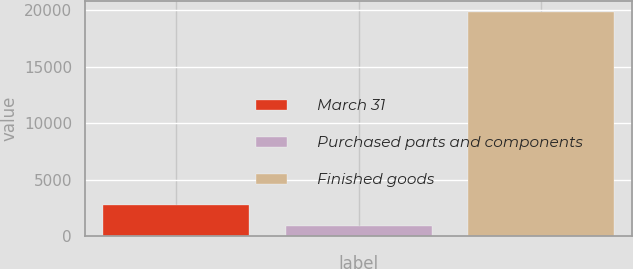Convert chart. <chart><loc_0><loc_0><loc_500><loc_500><bar_chart><fcel>March 31<fcel>Purchased parts and components<fcel>Finished goods<nl><fcel>2787.2<fcel>892<fcel>19844<nl></chart> 